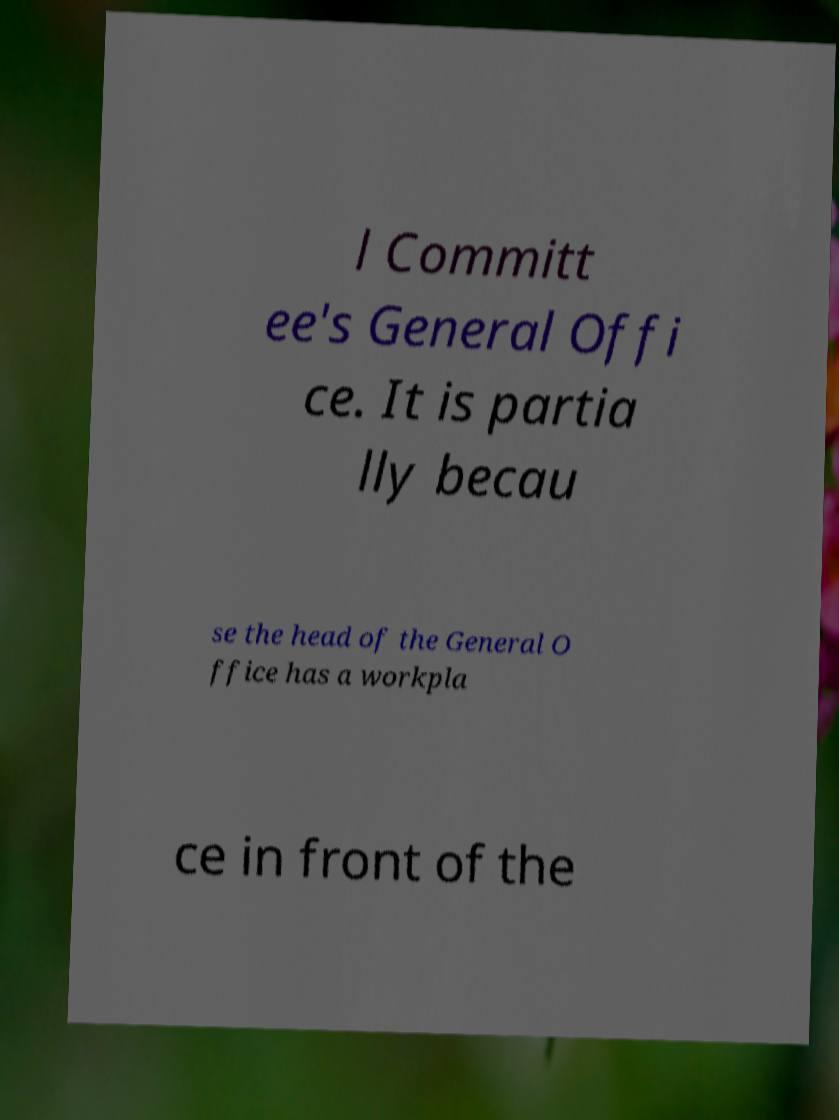What messages or text are displayed in this image? I need them in a readable, typed format. l Committ ee's General Offi ce. It is partia lly becau se the head of the General O ffice has a workpla ce in front of the 